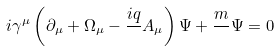Convert formula to latex. <formula><loc_0><loc_0><loc_500><loc_500>i \gamma ^ { \mu } \left ( \partial _ { \mu } + \Omega _ { \mu } - \frac { i q } { } A _ { \mu } \right ) \Psi + \frac { m } { } \Psi = 0</formula> 